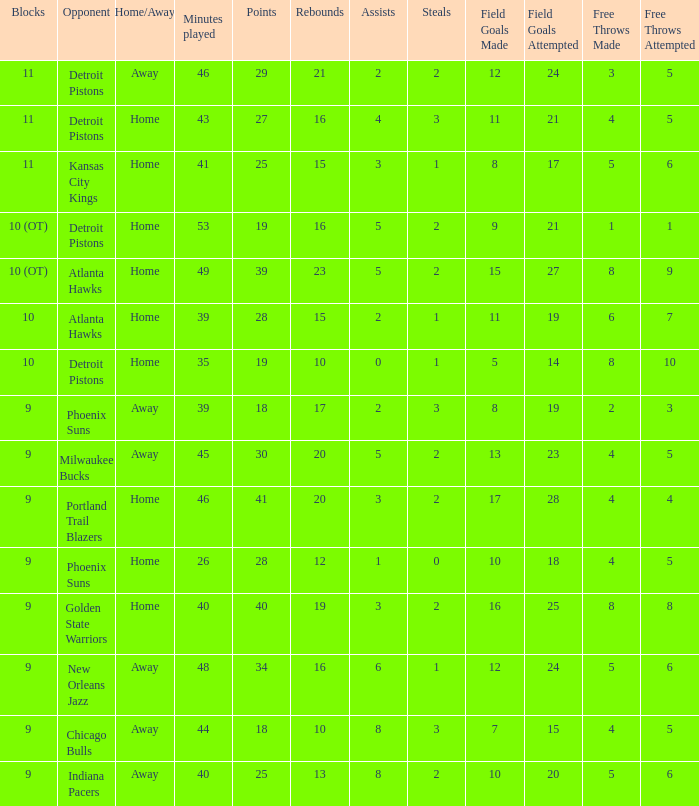How many minutes were played when there were 18 points and the opponent was Chicago Bulls? 1.0. 